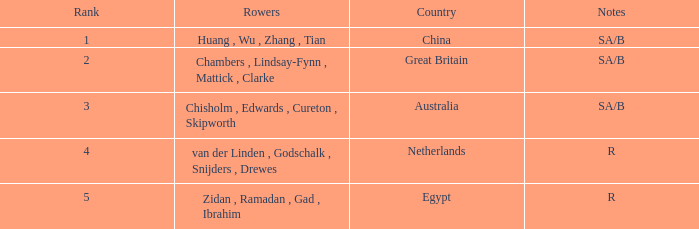What country is ranked larger than 4? Egypt. 